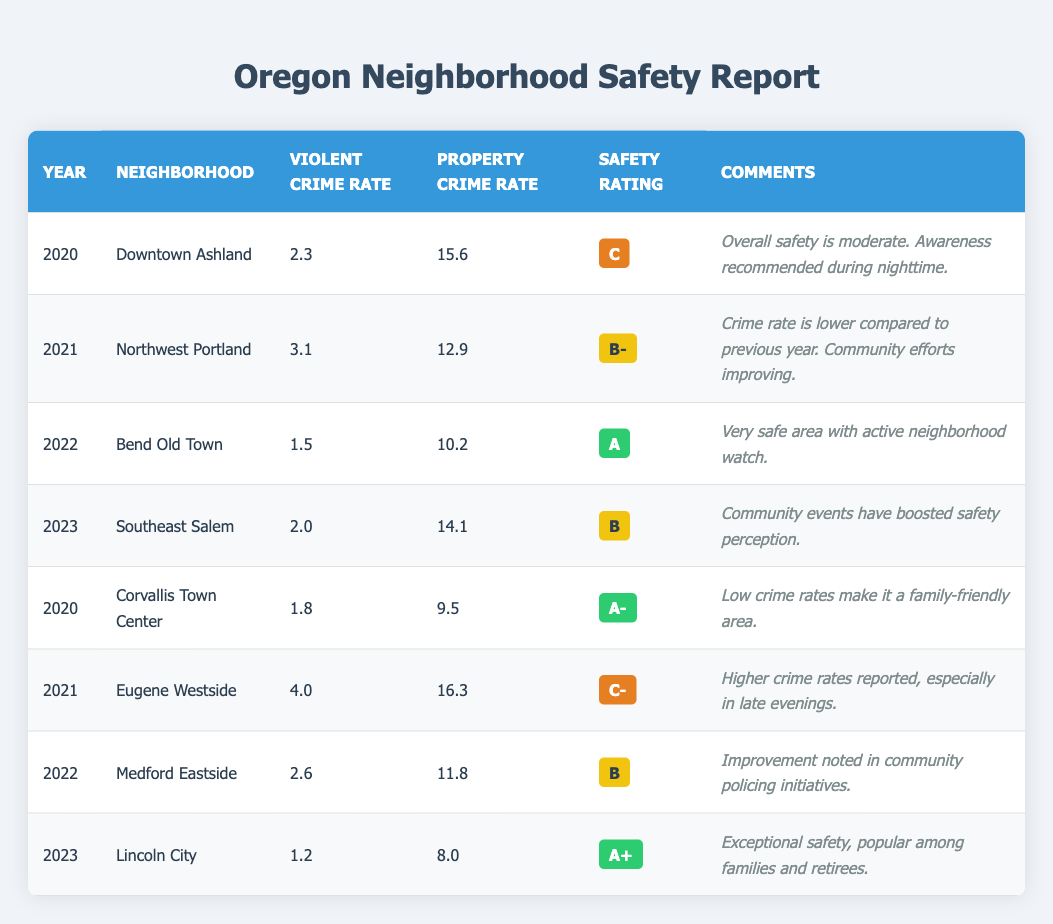What is the Violent Crime Rate for Lincoln City in 2023? Referring to the table, in the year 2023, the Violent Crime Rate for Lincoln City is listed as 1.2.
Answer: 1.2 What neighborhood had the highest Property Crime Rate in 2021? Looking at the table, the Property Crime Rate for Eugene Westside in 2021 is 16.3, which is higher than any other neighborhood for that year.
Answer: Eugene Westside Did Bend Old Town have a Safety Rating of A or higher in 2022? Checking the table, Bend Old Town's Safety Rating in 2022 is A, which meets the criteria of being A or higher.
Answer: Yes Calculate the average Violent Crime Rate from the years 2020 to 2023. To find the average, we sum the Violent Crime Rates: (2.3 + 3.1 + 1.5 + 2.0 + 1.8 + 4.0 + 2.6 + 1.2) = 18.5. There are 8 entries, so we divide 18.5 by 8, resulting in an average of 2.3125.
Answer: 2.3125 Which neighborhood had the lowest Safety Rating in 2021? The table shows that Eugene Westside in 2021 had a Safety Rating of C-, the lowest rating among the neighborhoods listed for that year.
Answer: Eugene Westside Is it true that the Property Crime Rate increased from 2020 to 2021 in Corvallis Town Center? In 2020, the Property Crime Rate in Corvallis Town Center was 9.5, and in 2021, it did not appear for this neighborhood for the same year as the data shifts to another neighborhood. Therefore, this comparison cannot be drawn, and the statement is false.
Answer: No What is the difference in Violent Crime Rate between Downtown Ashland in 2020 and Eugene Westside in 2021? The Violent Crime Rate for Downtown Ashland in 2020 is 2.3, while for Eugene Westside in 2021 it is 4.0. The difference is 4.0 - 2.3 = 1.7.
Answer: 1.7 How many neighborhoods received a Safety Rating of A or higher in the provided data? By reviewing the table, Bend Old Town has an A rating, Corvallis Town Center has an A-, and Lincoln City has an A+. This totals to 3 neighborhoods with A or higher ratings.
Answer: 3 Explain whether the safety perception in Southeast Salem improved in 2023. The table indicates that in 2023, community events reportedly boosted the safety perception in Southeast Salem, suggesting that people felt safer compared to previous times. Thus, the perception did improve.
Answer: Yes 